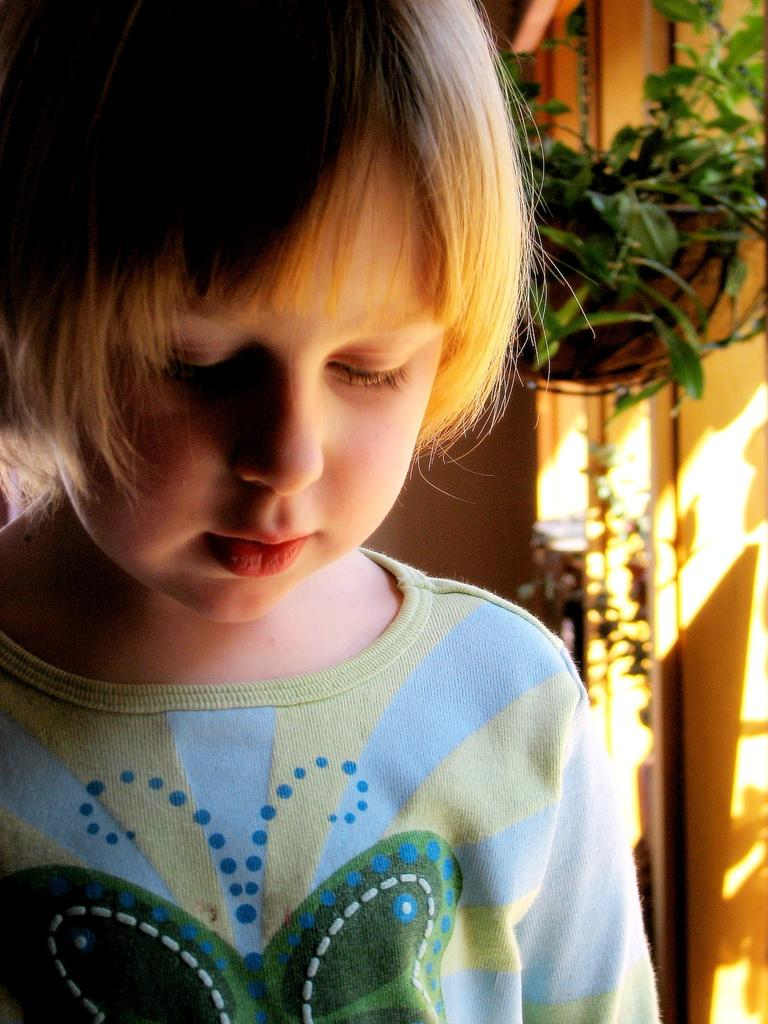What is the main subject in the foreground of the image? There is a kid in the foreground of the image. What is the kid wearing? The kid is wearing a t-shirt. What can be seen in the background of the image? There is a houseplant and a wall in the background of the image. What type of rabbit can be seen in the hospital in the image? There is no rabbit or hospital present in the image. 